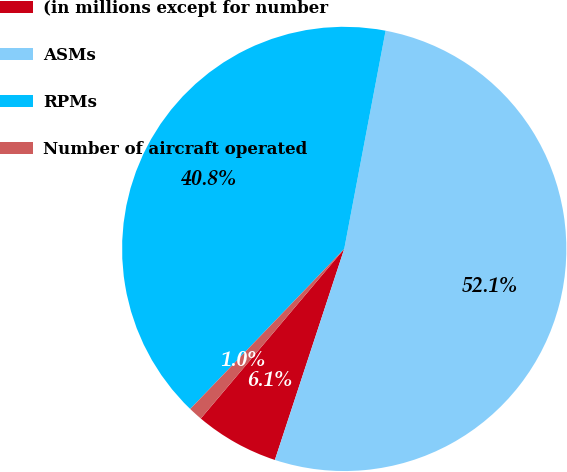Convert chart to OTSL. <chart><loc_0><loc_0><loc_500><loc_500><pie_chart><fcel>(in millions except for number<fcel>ASMs<fcel>RPMs<fcel>Number of aircraft operated<nl><fcel>6.12%<fcel>52.07%<fcel>40.79%<fcel>1.02%<nl></chart> 